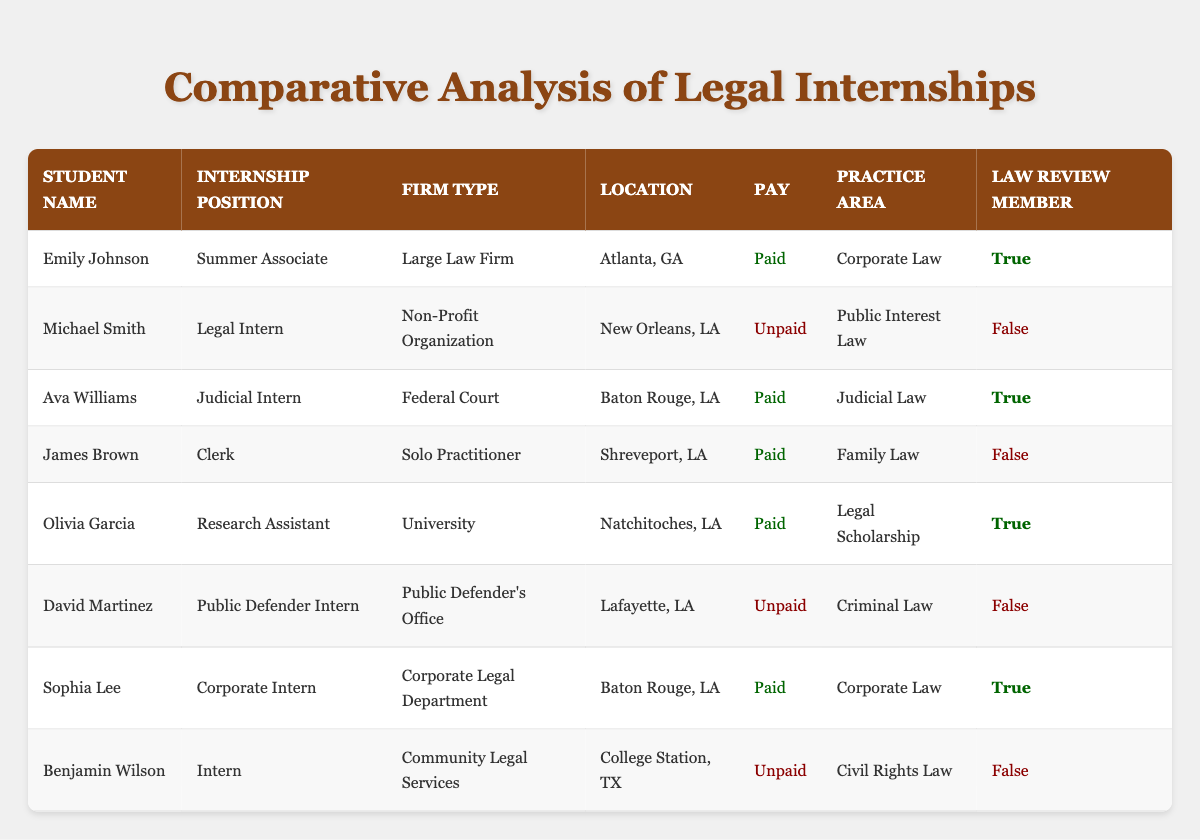What is the total number of students who secured paid internships? From the table, I look for the "Pay" column and count the rows labeled as "Paid." These rows belong to Emily Johnson, Ava Williams, Olivia Garcia, James Brown, and Sophia Lee, making it a total of 5 students.
Answer: 5 How many different practice areas are represented by the internships? By examining the "Practice Area" column, I identify the unique areas listed: Corporate Law, Public Interest Law, Judicial Law, Family Law, Legal Scholarship, Criminal Law, and Civil Rights Law. Counting these gives me 7 distinct practice areas.
Answer: 7 Does Sophia Lee hold a position at a Large Law Firm? I check Sophia Lee's "Firm Type" and see it's labeled as "Corporate Legal Department." Since this does not match "Large Law Firm," the answer is no.
Answer: No Which student is interning at a Federal Court? I look at the "Firm Type" column and locate "Federal Court," which corresponds to Ava Williams. Thus, Ava Williams is the student interning at a Federal Court.
Answer: Ava Williams What percentage of second-year students are Law Review members? There are 8 students total listed in the table. I count those who are Law Review members: Emily Johnson, Ava Williams, Olivia Garcia, and Sophia Lee (4 students). To find the percentage: (4/8) * 100 = 50%.
Answer: 50% Is it true that all unpaid internships are with non-profit organizations? I review the "Firm Type" for all unpaid internships: Michael Smith is with a Non-Profit Organization, and David Martinez is at a Public Defender's Office. Since the second unpaid internship does not match, the statement is false.
Answer: False Who holds the highest internship position among the second-year students based on typical hierarchy? I assess internship positions: "Summer Associate" is typically higher than "Legal Intern," "Judicial Intern," or "Clerk." It appears Emily Johnson holds the highest position as a Summer Associate at a Large Law Firm.
Answer: Emily Johnson How many students are from Louisiana? I review the "Location" column and identify the students who are listed from Louisiana: Michael Smith, Ava Williams, James Brown, Olivia Garcia, David Martinez, and Sophia Lee, which totals 6 students from Louisiana.
Answer: 6 